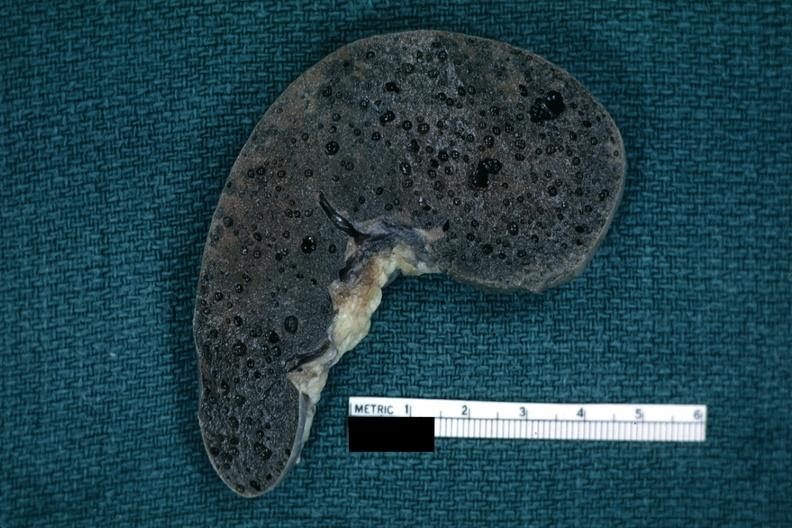s clostridial postmortem growth present?
Answer the question using a single word or phrase. Yes 